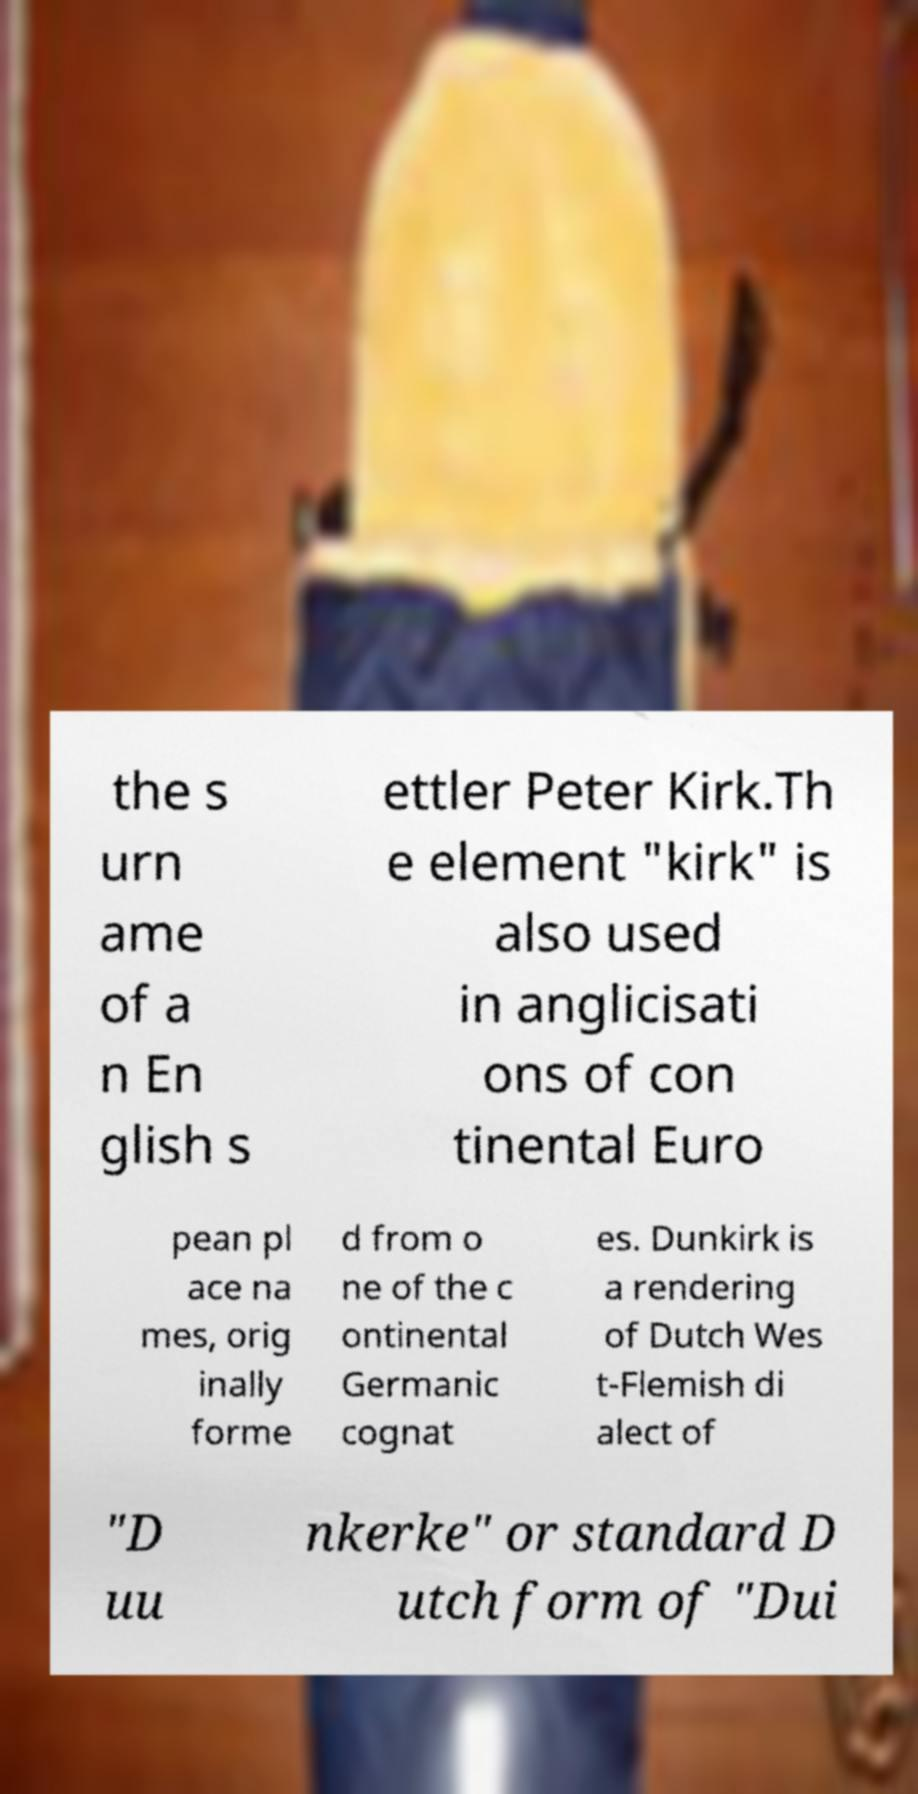I need the written content from this picture converted into text. Can you do that? the s urn ame of a n En glish s ettler Peter Kirk.Th e element "kirk" is also used in anglicisati ons of con tinental Euro pean pl ace na mes, orig inally forme d from o ne of the c ontinental Germanic cognat es. Dunkirk is a rendering of Dutch Wes t-Flemish di alect of "D uu nkerke" or standard D utch form of "Dui 